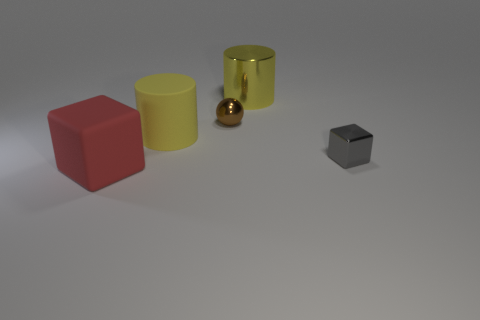The thing that is the same color as the big metallic cylinder is what size?
Your answer should be very brief. Large. What shape is the large thing that is the same color as the big metallic cylinder?
Offer a terse response. Cylinder. Is there any other thing that has the same material as the brown thing?
Provide a short and direct response. Yes. What number of small things are red balls or rubber cubes?
Your answer should be very brief. 0. Do the small thing that is to the left of the big yellow metallic cylinder and the gray metal thing have the same shape?
Offer a terse response. No. Is the number of red blocks less than the number of blue cubes?
Your response must be concise. No. Is there any other thing of the same color as the metallic block?
Make the answer very short. No. There is a thing that is behind the tiny brown shiny thing; what is its shape?
Your answer should be compact. Cylinder. There is a big cube; is its color the same as the big cylinder in front of the shiny cylinder?
Give a very brief answer. No. Are there an equal number of yellow metal things that are left of the metallic sphere and tiny brown things that are in front of the matte block?
Keep it short and to the point. Yes. 